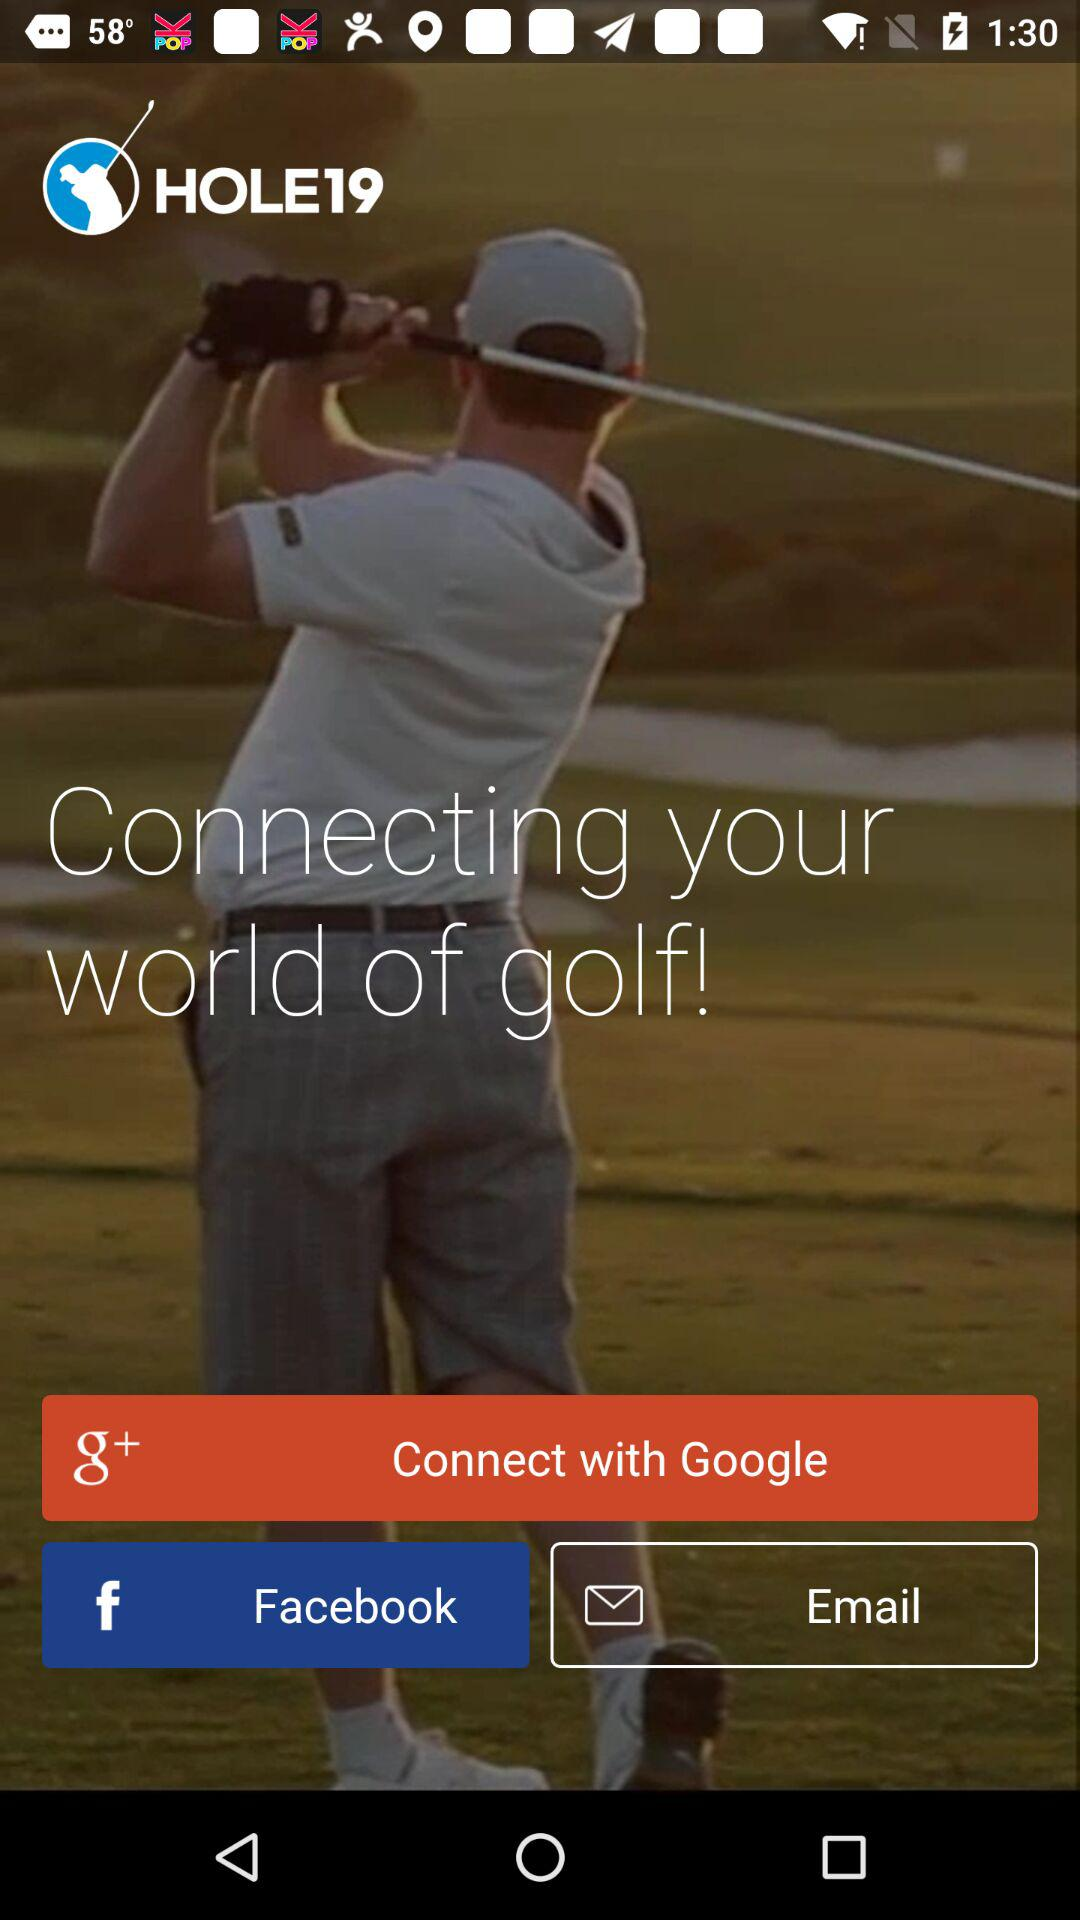What is the application name? The application name is "HOLE19". 